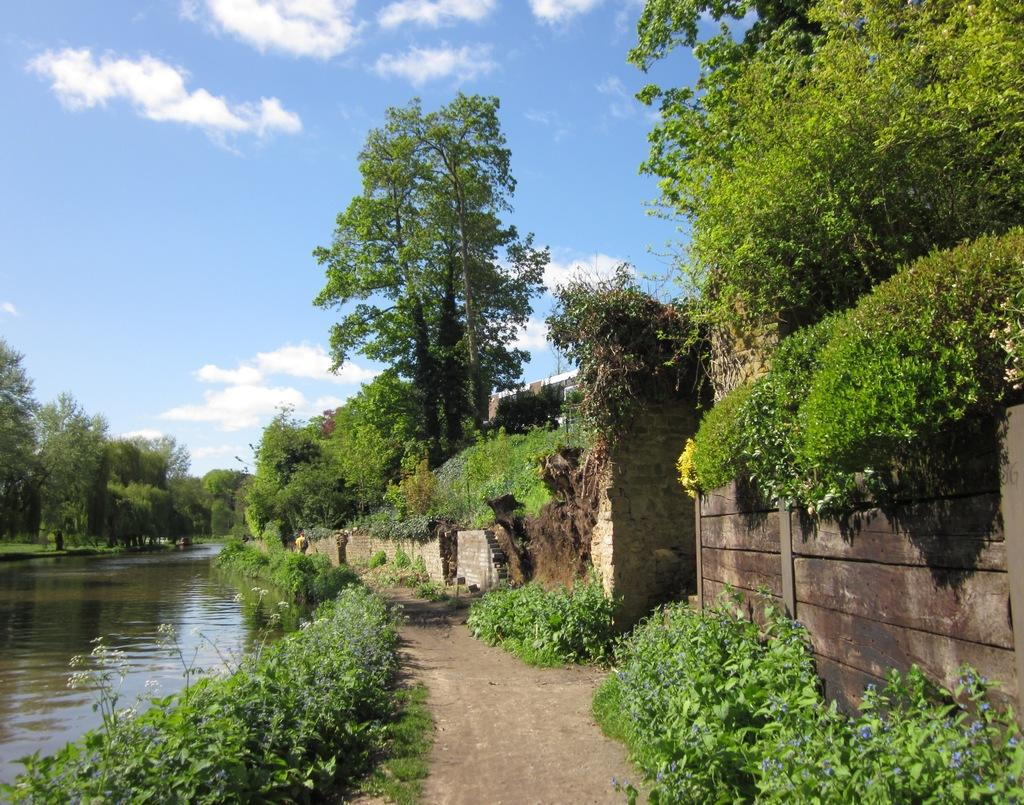What is present in the image that is liquid? There is water visible in the image. What type of flowers can be seen in the image? There are flowers in white color in the image. What color are the plants and trees in the image? There are plants and trees in green color in the image. What colors make up the sky in the image? The sky is a combination of white and blue color in the image. Can you tell me how many snails are crawling on the bed in the image? There is no bed or snails present in the image. What type of sorting method is being used for the plants in the image? There is no sorting method being used for the plants in the image; they are simply growing in their natural state. 